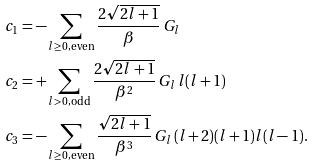Convert formula to latex. <formula><loc_0><loc_0><loc_500><loc_500>c _ { 1 } & = - \sum _ { l \geq 0 , \, \text {even} } \frac { 2 \sqrt { 2 l + 1 } } { \beta } \, G _ { l } \\ c _ { 2 } & = + \sum _ { l > 0 , \, \text {odd} } \frac { 2 \sqrt { 2 l + 1 } } { \beta ^ { 2 } } \, G _ { l } \, l ( l + 1 ) \\ c _ { 3 } & = - \sum _ { l \geq 0 , \, \text {even} } \frac { \sqrt { 2 l + 1 } } { \beta ^ { 3 } } \, G _ { l } \, ( l + 2 ) ( l + 1 ) l ( l - 1 ) .</formula> 